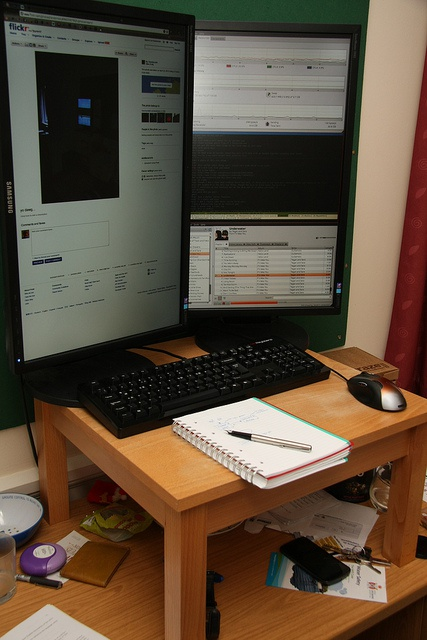Describe the objects in this image and their specific colors. I can see tv in black and gray tones, tv in black, darkgray, and gray tones, keyboard in black, brown, gray, and orange tones, book in black, lightgray, and darkgray tones, and cell phone in black and gray tones in this image. 